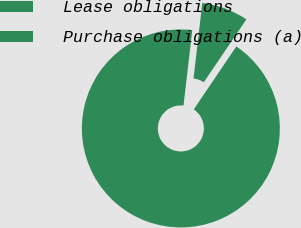Convert chart. <chart><loc_0><loc_0><loc_500><loc_500><pie_chart><fcel>Lease obligations<fcel>Purchase obligations (a)<nl><fcel>7.63%<fcel>92.37%<nl></chart> 